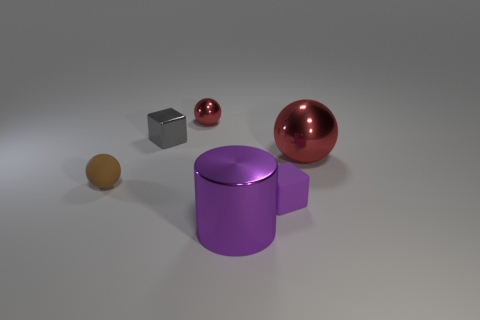Is there anything else that has the same size as the gray thing?
Offer a very short reply. Yes. The object that is the same color as the large cylinder is what size?
Offer a terse response. Small. What is the shape of the big object that is the same color as the tiny matte cube?
Keep it short and to the point. Cylinder. Is there any other thing of the same color as the small metallic cube?
Provide a short and direct response. No. Is there a matte thing behind the tiny ball that is in front of the red metal ball that is on the right side of the large metallic cylinder?
Your answer should be compact. No. What is the color of the tiny matte ball?
Ensure brevity in your answer.  Brown. Are there any tiny brown rubber balls in front of the purple cylinder?
Your answer should be compact. No. There is a tiny red thing; does it have the same shape as the metallic thing that is to the right of the purple shiny cylinder?
Give a very brief answer. Yes. How many other objects are the same material as the tiny brown sphere?
Keep it short and to the point. 1. What color is the shiny object in front of the tiny object that is to the right of the red metallic ball to the left of the big shiny cylinder?
Ensure brevity in your answer.  Purple. 